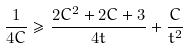<formula> <loc_0><loc_0><loc_500><loc_500>\frac { 1 } { 4 C } \geq \frac { 2 C ^ { 2 } + 2 C + 3 } { 4 t } + \frac { C } { t ^ { 2 } }</formula> 